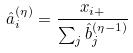<formula> <loc_0><loc_0><loc_500><loc_500>\hat { a } _ { i } ^ { ( \eta ) } = \frac { x _ { i + } } { \sum _ { j } \hat { b } _ { j } ^ { ( \eta - 1 ) } }</formula> 